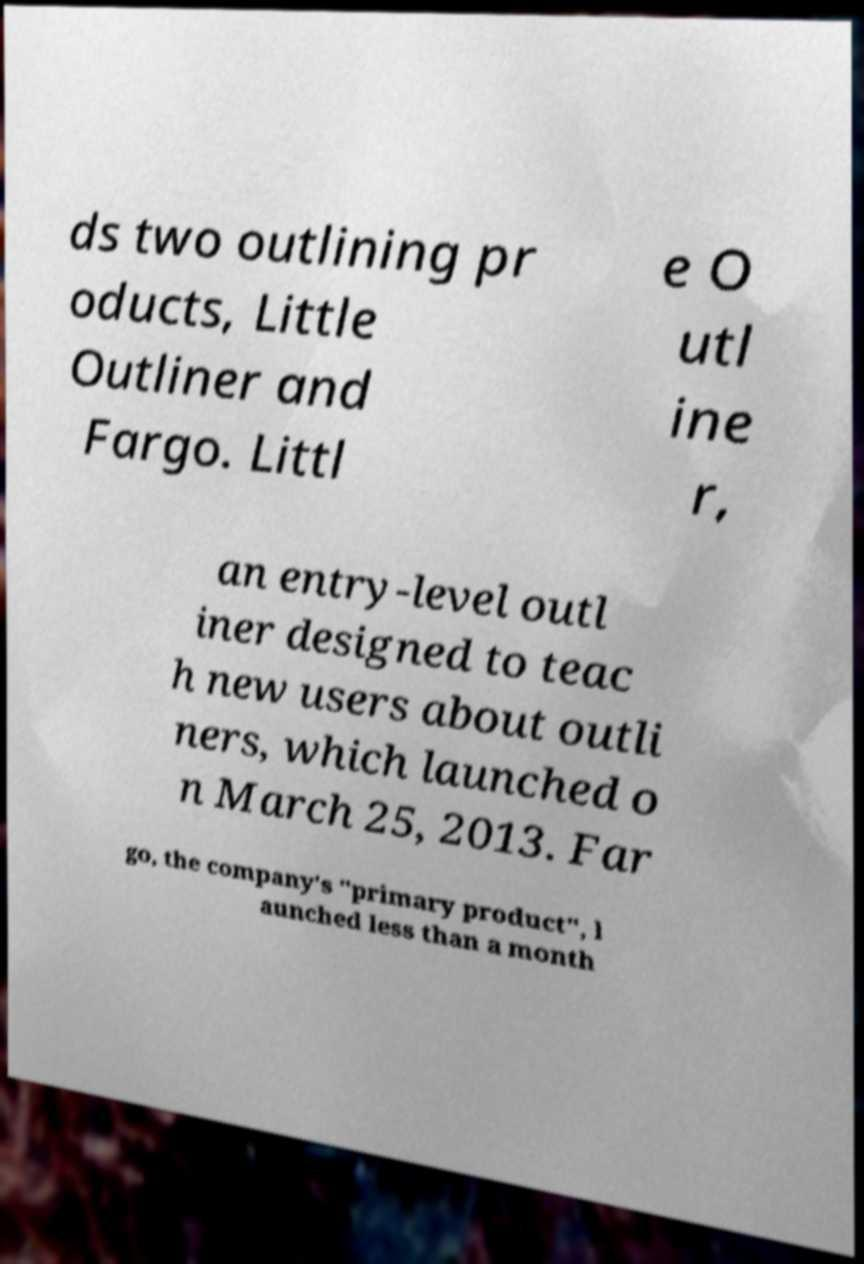For documentation purposes, I need the text within this image transcribed. Could you provide that? ds two outlining pr oducts, Little Outliner and Fargo. Littl e O utl ine r, an entry-level outl iner designed to teac h new users about outli ners, which launched o n March 25, 2013. Far go, the company's "primary product", l aunched less than a month 